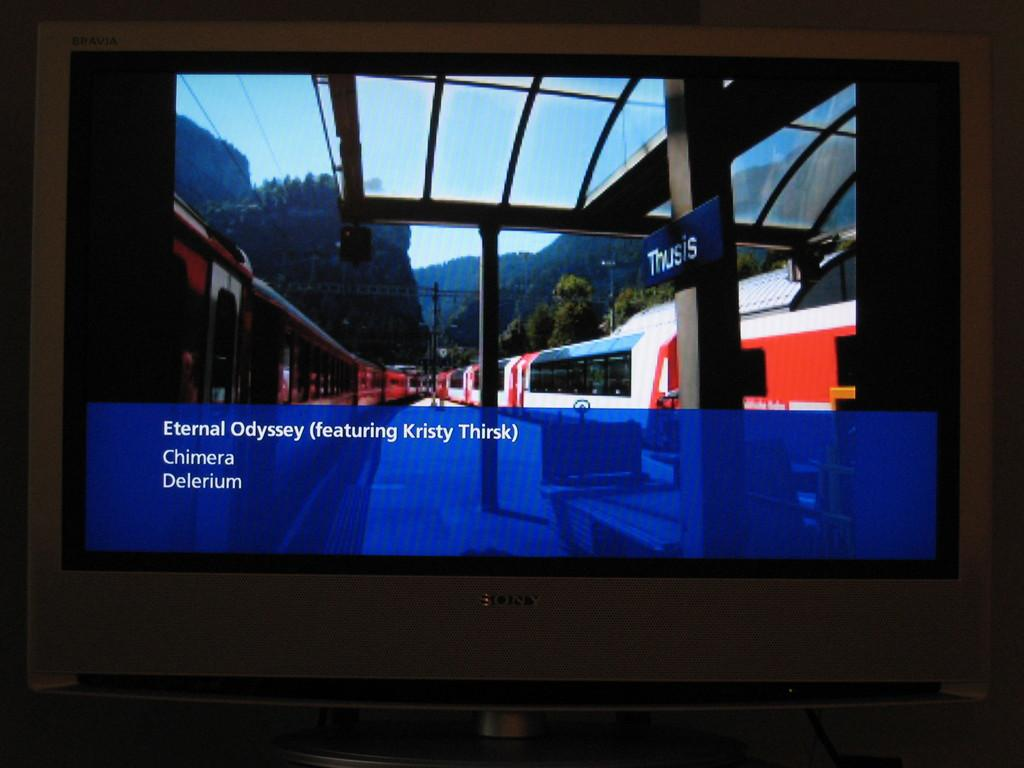<image>
Render a clear and concise summary of the photo. the word eternal is on the bottom left of the screen 